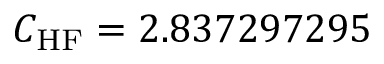Convert formula to latex. <formula><loc_0><loc_0><loc_500><loc_500>C _ { H F } = 2 . 8 3 7 2 9 7 2 9 5</formula> 